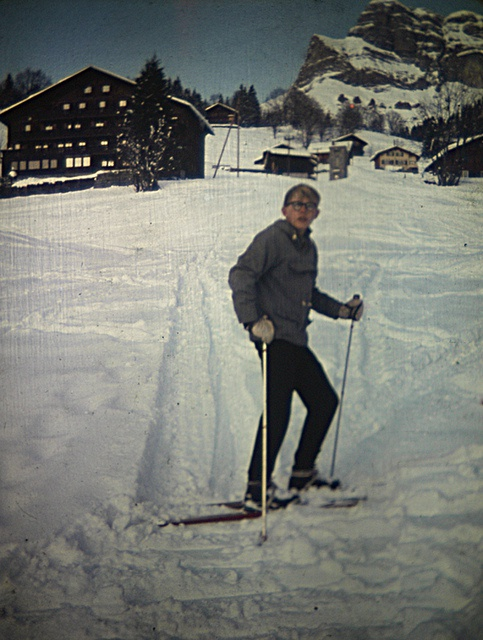Describe the objects in this image and their specific colors. I can see people in black, gray, and darkgray tones and skis in black and gray tones in this image. 